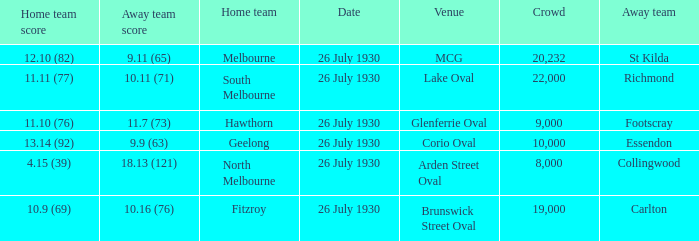When was Fitzroy the home team? 26 July 1930. 